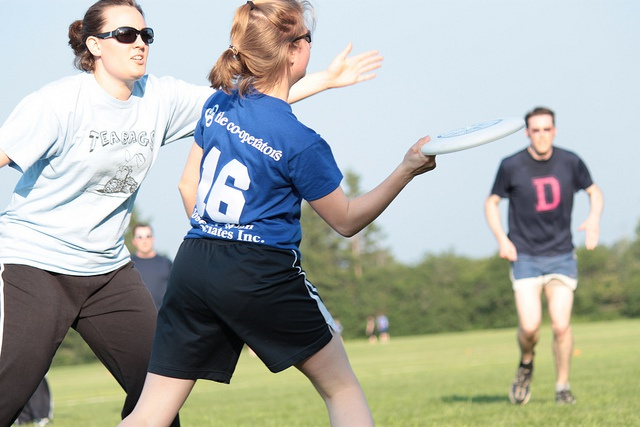Describe the objects in this image and their specific colors. I can see people in lightblue, black, blue, white, and tan tones, people in lightblue, white, gray, and black tones, people in lightblue, gray, white, tan, and lightpink tones, frisbee in lightblue, lightgray, and darkgray tones, and people in lightblue, gray, lightpink, lightgray, and tan tones in this image. 